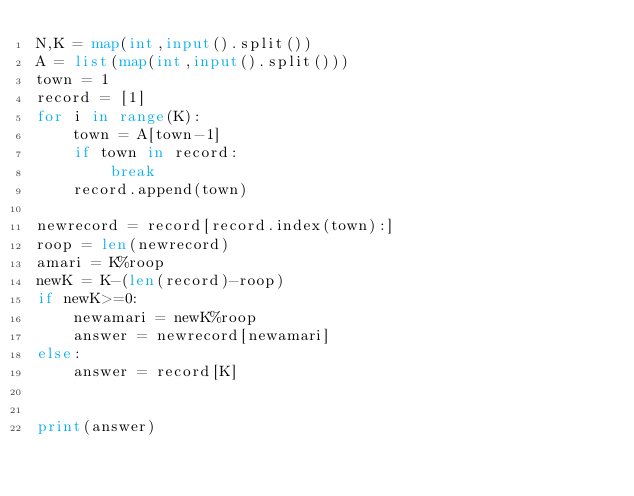<code> <loc_0><loc_0><loc_500><loc_500><_Python_>N,K = map(int,input().split())
A = list(map(int,input().split()))
town = 1
record = [1]
for i in range(K):
    town = A[town-1]
    if town in record:
        break
    record.append(town)
    
newrecord = record[record.index(town):]
roop = len(newrecord)
amari = K%roop
newK = K-(len(record)-roop)
if newK>=0:
    newamari = newK%roop
    answer = newrecord[newamari]
else:
    answer = record[K]

    
print(answer)</code> 